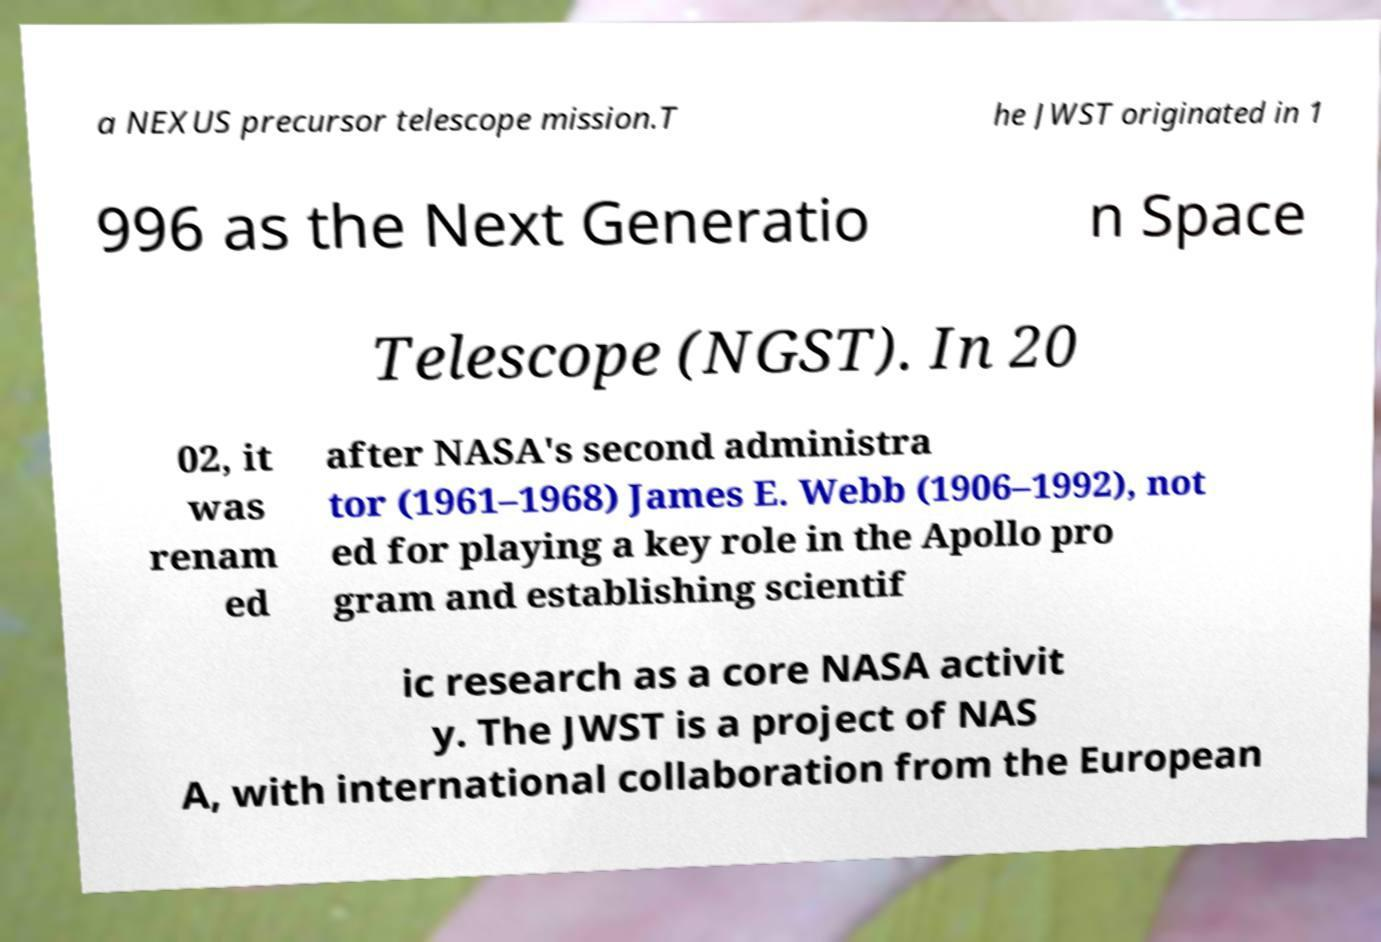Please read and relay the text visible in this image. What does it say? a NEXUS precursor telescope mission.T he JWST originated in 1 996 as the Next Generatio n Space Telescope (NGST). In 20 02, it was renam ed after NASA's second administra tor (1961–1968) James E. Webb (1906–1992), not ed for playing a key role in the Apollo pro gram and establishing scientif ic research as a core NASA activit y. The JWST is a project of NAS A, with international collaboration from the European 